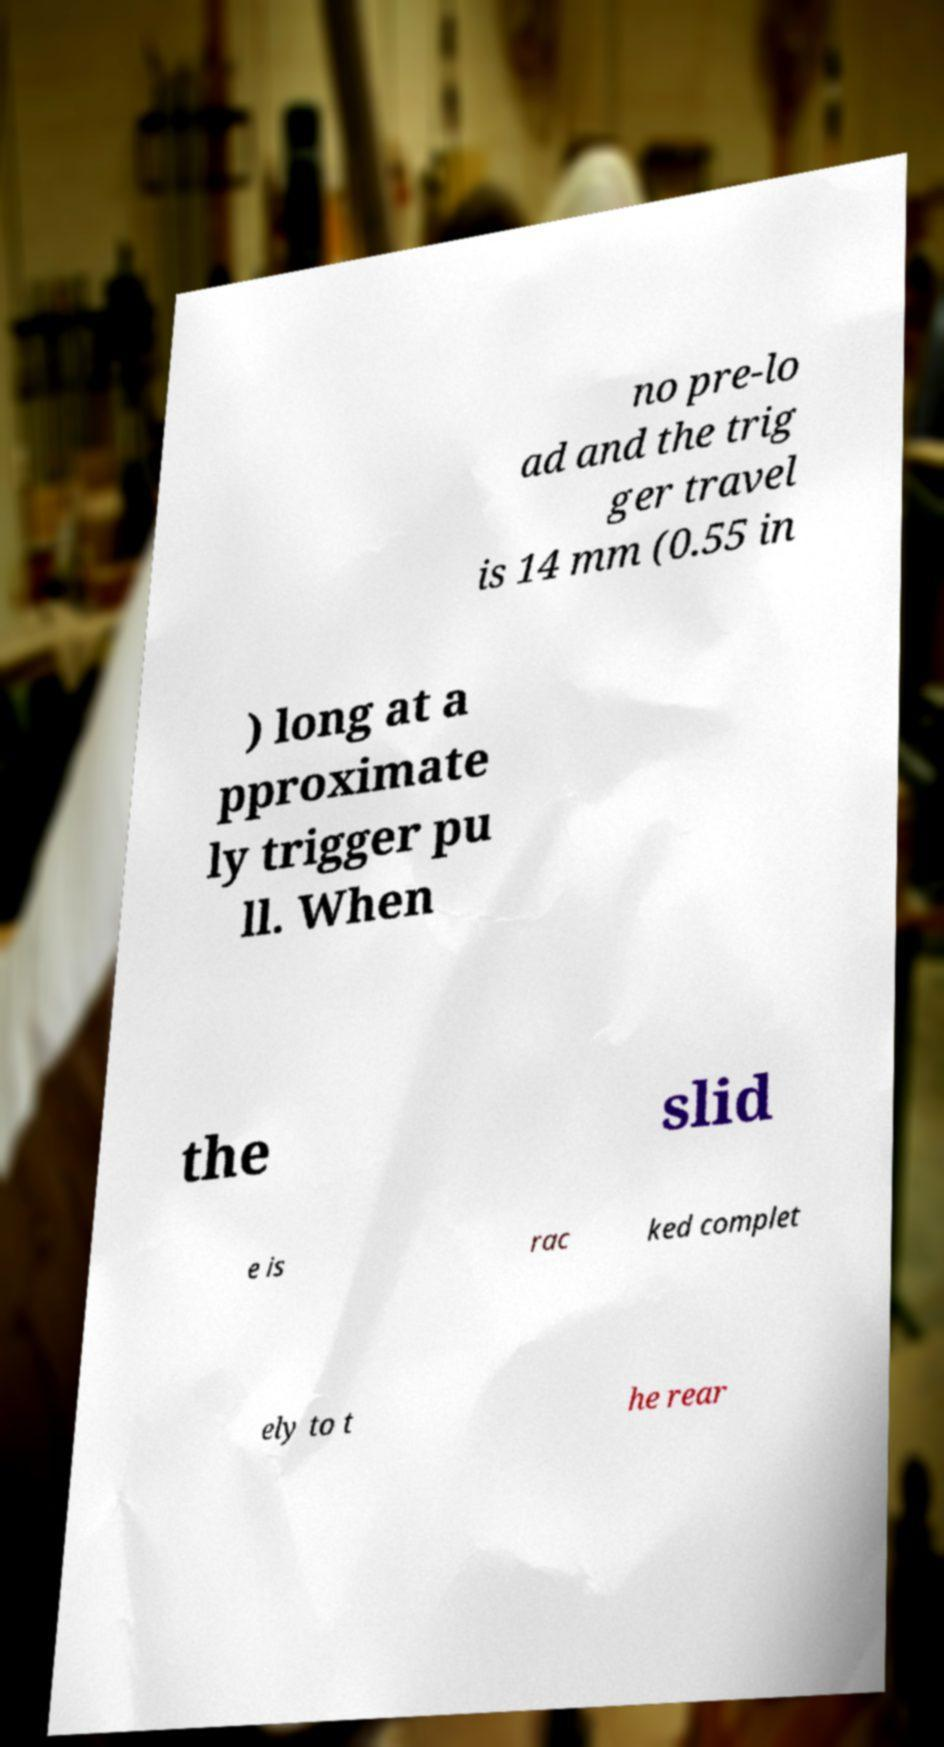Can you read and provide the text displayed in the image?This photo seems to have some interesting text. Can you extract and type it out for me? no pre-lo ad and the trig ger travel is 14 mm (0.55 in ) long at a pproximate ly trigger pu ll. When the slid e is rac ked complet ely to t he rear 